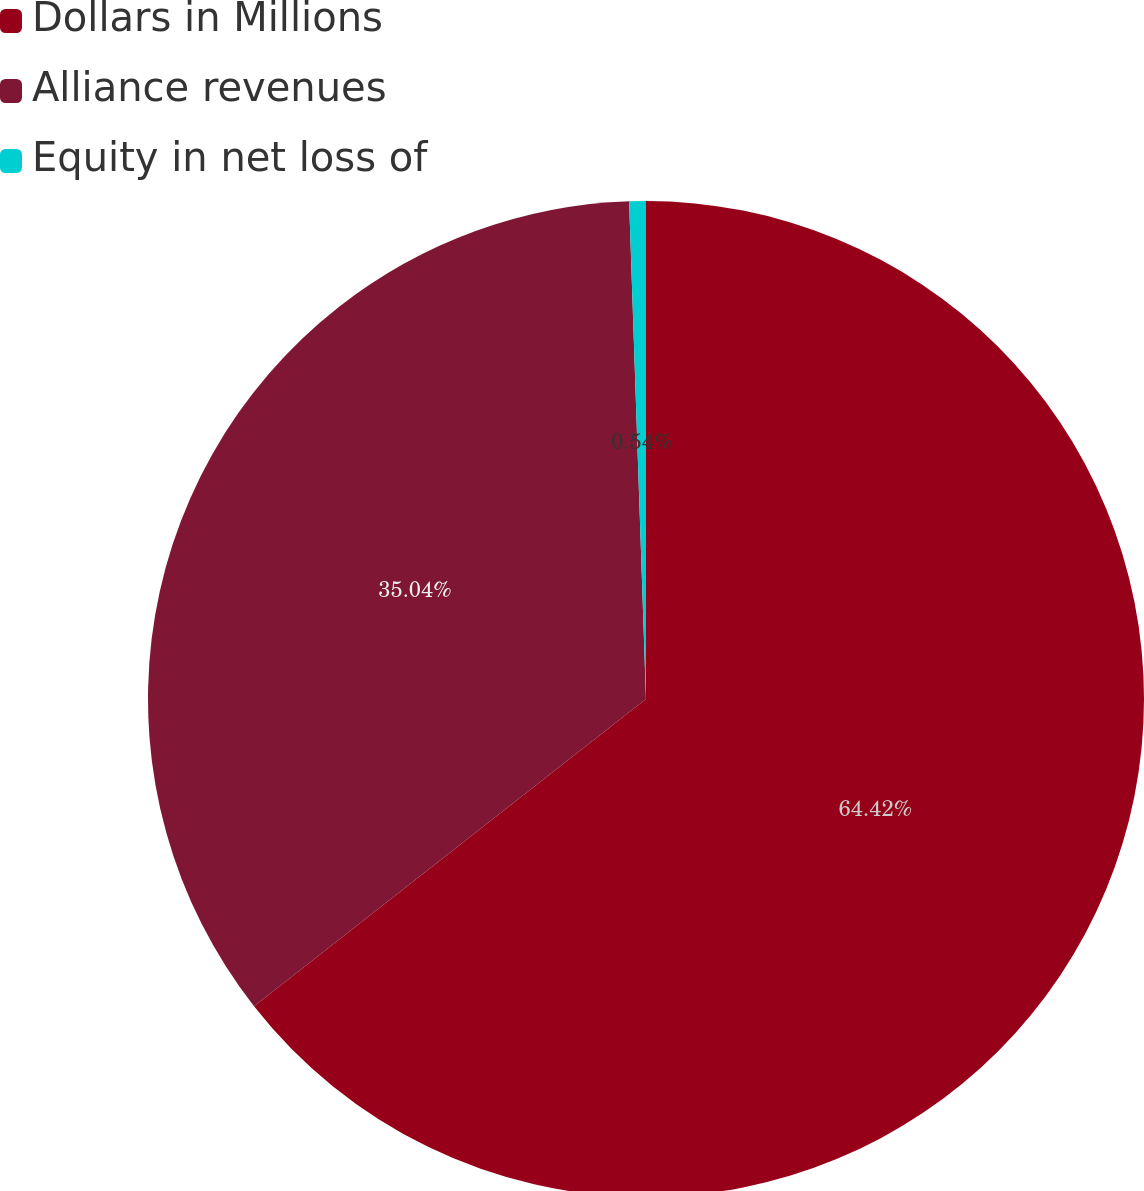<chart> <loc_0><loc_0><loc_500><loc_500><pie_chart><fcel>Dollars in Millions<fcel>Alliance revenues<fcel>Equity in net loss of<nl><fcel>64.42%<fcel>35.04%<fcel>0.54%<nl></chart> 